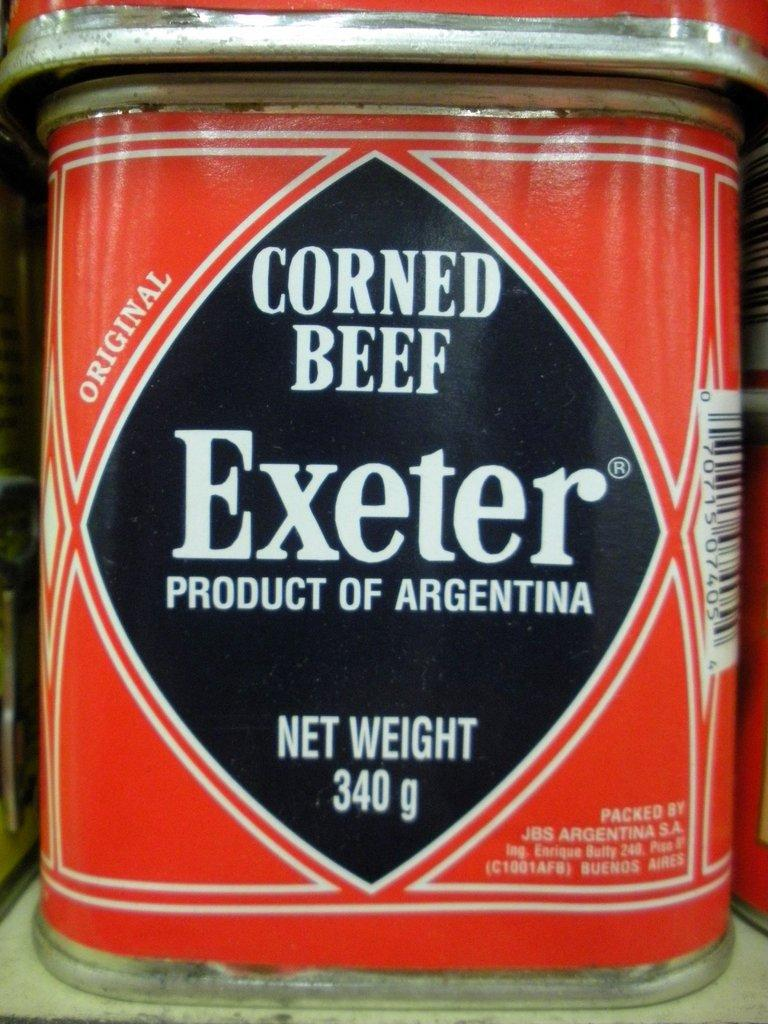<image>
Render a clear and concise summary of the photo. A can of Corned Beef that says Exeter Product of Argentina. 